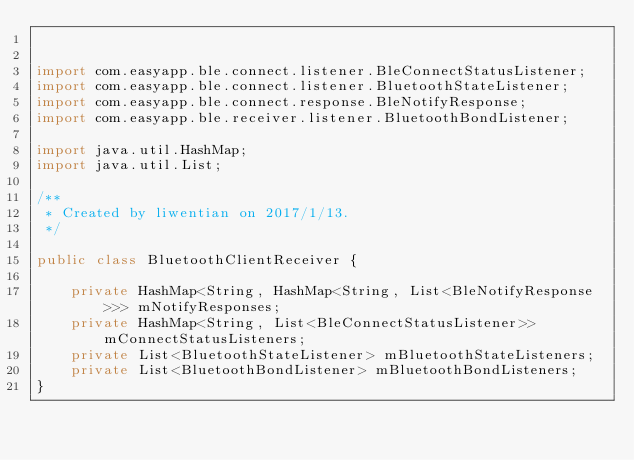Convert code to text. <code><loc_0><loc_0><loc_500><loc_500><_Java_>

import com.easyapp.ble.connect.listener.BleConnectStatusListener;
import com.easyapp.ble.connect.listener.BluetoothStateListener;
import com.easyapp.ble.connect.response.BleNotifyResponse;
import com.easyapp.ble.receiver.listener.BluetoothBondListener;

import java.util.HashMap;
import java.util.List;

/**
 * Created by liwentian on 2017/1/13.
 */

public class BluetoothClientReceiver {

    private HashMap<String, HashMap<String, List<BleNotifyResponse>>> mNotifyResponses;
    private HashMap<String, List<BleConnectStatusListener>> mConnectStatusListeners;
    private List<BluetoothStateListener> mBluetoothStateListeners;
    private List<BluetoothBondListener> mBluetoothBondListeners;
}
</code> 